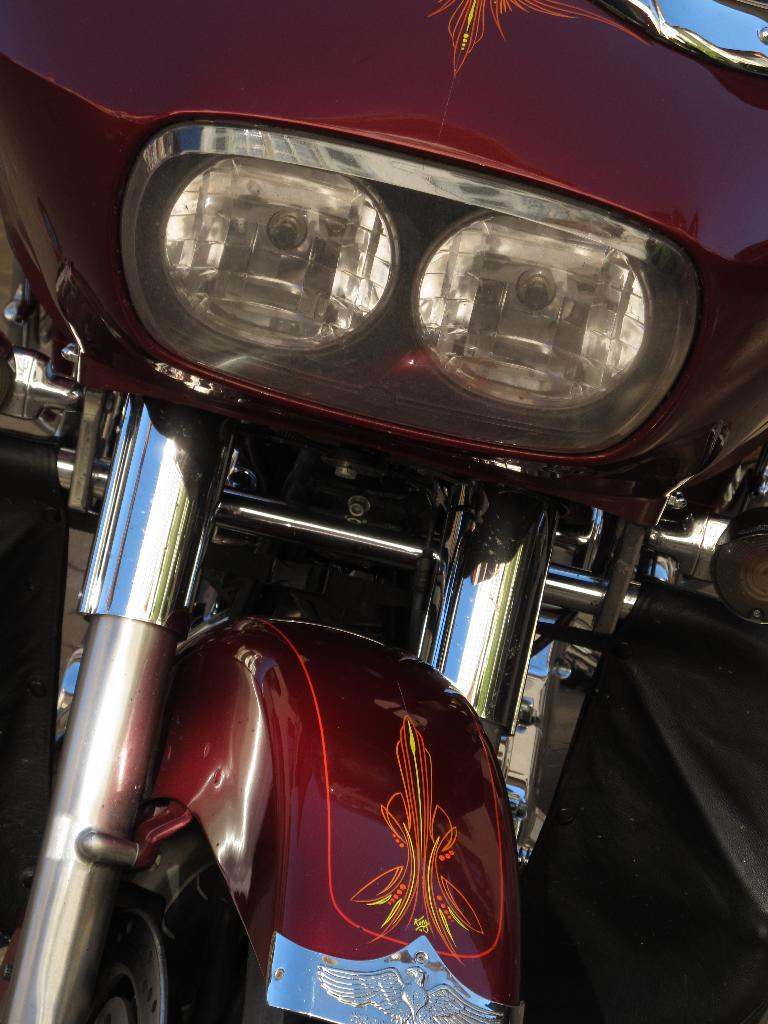What is the main subject of the image? The main subject of the image is a vehicle. Can you describe the vehicle in more detail? Unfortunately, the image is a zoomed-in picture, so it's difficult to provide more details about the vehicle. What type of cable is used to connect the gun to the band in the image? There is no cable, gun, or band present in the image. The image only features a zoomed-in picture of a vehicle. 